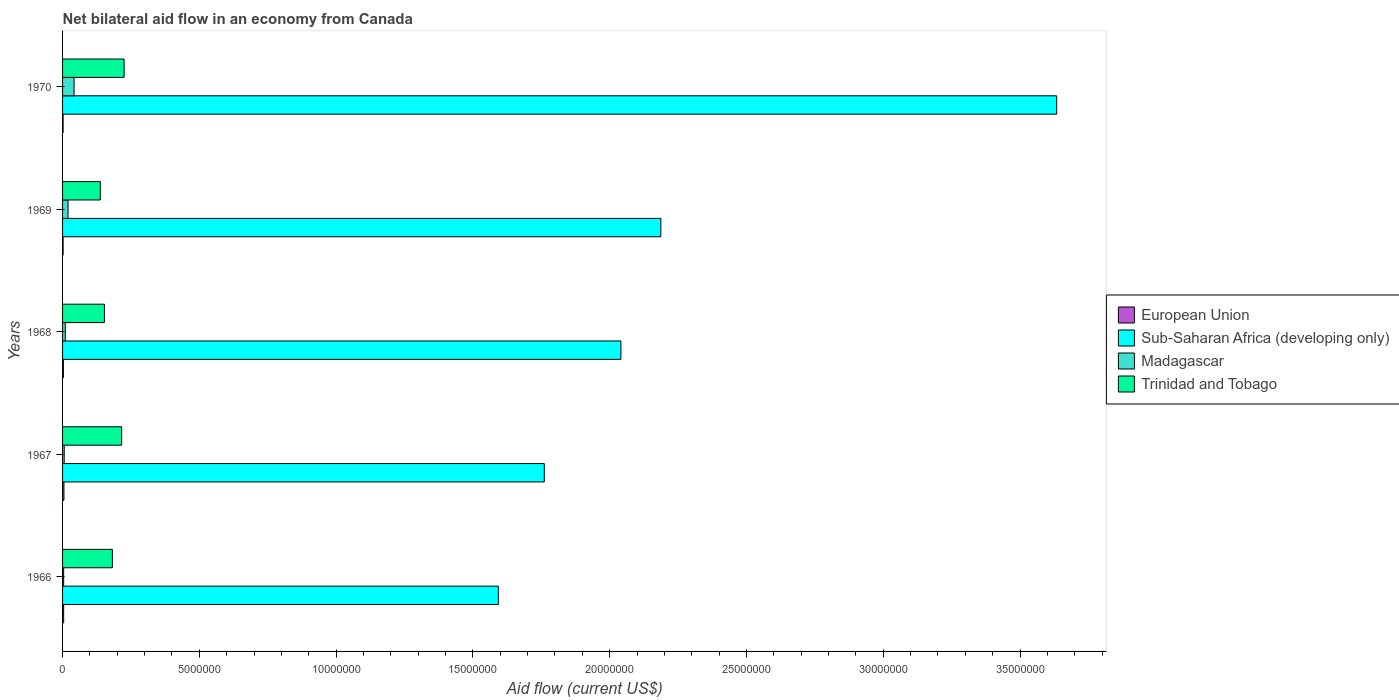Are the number of bars on each tick of the Y-axis equal?
Keep it short and to the point. Yes. What is the label of the 5th group of bars from the top?
Keep it short and to the point. 1966. In how many cases, is the number of bars for a given year not equal to the number of legend labels?
Your answer should be very brief. 0. What is the net bilateral aid flow in Sub-Saharan Africa (developing only) in 1970?
Keep it short and to the point. 3.63e+07. Across all years, what is the maximum net bilateral aid flow in Trinidad and Tobago?
Ensure brevity in your answer.  2.25e+06. Across all years, what is the minimum net bilateral aid flow in Trinidad and Tobago?
Your answer should be compact. 1.38e+06. In which year was the net bilateral aid flow in Madagascar maximum?
Your answer should be compact. 1970. In which year was the net bilateral aid flow in Madagascar minimum?
Your answer should be very brief. 1966. What is the total net bilateral aid flow in European Union in the graph?
Offer a very short reply. 1.60e+05. What is the difference between the net bilateral aid flow in Trinidad and Tobago in 1967 and that in 1970?
Your answer should be very brief. -9.00e+04. What is the difference between the net bilateral aid flow in Trinidad and Tobago in 1970 and the net bilateral aid flow in Madagascar in 1969?
Your answer should be compact. 2.05e+06. What is the average net bilateral aid flow in Trinidad and Tobago per year?
Offer a terse response. 1.83e+06. In the year 1969, what is the difference between the net bilateral aid flow in Madagascar and net bilateral aid flow in Trinidad and Tobago?
Keep it short and to the point. -1.18e+06. In how many years, is the net bilateral aid flow in Sub-Saharan Africa (developing only) greater than 17000000 US$?
Your answer should be compact. 4. What is the ratio of the net bilateral aid flow in Madagascar in 1966 to that in 1969?
Offer a terse response. 0.2. Is the difference between the net bilateral aid flow in Madagascar in 1968 and 1970 greater than the difference between the net bilateral aid flow in Trinidad and Tobago in 1968 and 1970?
Your answer should be compact. Yes. What is the difference between the highest and the second highest net bilateral aid flow in European Union?
Keep it short and to the point. 10000. What is the difference between the highest and the lowest net bilateral aid flow in Sub-Saharan Africa (developing only)?
Make the answer very short. 2.04e+07. In how many years, is the net bilateral aid flow in Madagascar greater than the average net bilateral aid flow in Madagascar taken over all years?
Ensure brevity in your answer.  2. Is the sum of the net bilateral aid flow in Madagascar in 1966 and 1969 greater than the maximum net bilateral aid flow in European Union across all years?
Give a very brief answer. Yes. Is it the case that in every year, the sum of the net bilateral aid flow in Sub-Saharan Africa (developing only) and net bilateral aid flow in Madagascar is greater than the sum of net bilateral aid flow in European Union and net bilateral aid flow in Trinidad and Tobago?
Provide a succinct answer. Yes. What does the 2nd bar from the top in 1966 represents?
Your response must be concise. Madagascar. Are all the bars in the graph horizontal?
Your response must be concise. Yes. How many years are there in the graph?
Offer a terse response. 5. Where does the legend appear in the graph?
Keep it short and to the point. Center right. How are the legend labels stacked?
Your answer should be compact. Vertical. What is the title of the graph?
Make the answer very short. Net bilateral aid flow in an economy from Canada. What is the label or title of the Y-axis?
Give a very brief answer. Years. What is the Aid flow (current US$) in Sub-Saharan Africa (developing only) in 1966?
Offer a terse response. 1.59e+07. What is the Aid flow (current US$) in Trinidad and Tobago in 1966?
Your response must be concise. 1.82e+06. What is the Aid flow (current US$) in European Union in 1967?
Your answer should be very brief. 5.00e+04. What is the Aid flow (current US$) in Sub-Saharan Africa (developing only) in 1967?
Offer a terse response. 1.76e+07. What is the Aid flow (current US$) in Madagascar in 1967?
Keep it short and to the point. 6.00e+04. What is the Aid flow (current US$) in Trinidad and Tobago in 1967?
Make the answer very short. 2.16e+06. What is the Aid flow (current US$) of European Union in 1968?
Provide a short and direct response. 3.00e+04. What is the Aid flow (current US$) in Sub-Saharan Africa (developing only) in 1968?
Offer a terse response. 2.04e+07. What is the Aid flow (current US$) in Trinidad and Tobago in 1968?
Offer a very short reply. 1.53e+06. What is the Aid flow (current US$) in Sub-Saharan Africa (developing only) in 1969?
Provide a succinct answer. 2.19e+07. What is the Aid flow (current US$) in Madagascar in 1969?
Offer a terse response. 2.00e+05. What is the Aid flow (current US$) in Trinidad and Tobago in 1969?
Your answer should be compact. 1.38e+06. What is the Aid flow (current US$) of Sub-Saharan Africa (developing only) in 1970?
Offer a very short reply. 3.63e+07. What is the Aid flow (current US$) of Trinidad and Tobago in 1970?
Provide a succinct answer. 2.25e+06. Across all years, what is the maximum Aid flow (current US$) in European Union?
Your answer should be compact. 5.00e+04. Across all years, what is the maximum Aid flow (current US$) in Sub-Saharan Africa (developing only)?
Give a very brief answer. 3.63e+07. Across all years, what is the maximum Aid flow (current US$) in Trinidad and Tobago?
Provide a succinct answer. 2.25e+06. Across all years, what is the minimum Aid flow (current US$) of Sub-Saharan Africa (developing only)?
Give a very brief answer. 1.59e+07. Across all years, what is the minimum Aid flow (current US$) in Madagascar?
Make the answer very short. 4.00e+04. Across all years, what is the minimum Aid flow (current US$) of Trinidad and Tobago?
Provide a short and direct response. 1.38e+06. What is the total Aid flow (current US$) in European Union in the graph?
Give a very brief answer. 1.60e+05. What is the total Aid flow (current US$) of Sub-Saharan Africa (developing only) in the graph?
Your response must be concise. 1.12e+08. What is the total Aid flow (current US$) in Madagascar in the graph?
Provide a short and direct response. 8.20e+05. What is the total Aid flow (current US$) of Trinidad and Tobago in the graph?
Make the answer very short. 9.14e+06. What is the difference between the Aid flow (current US$) of European Union in 1966 and that in 1967?
Provide a succinct answer. -10000. What is the difference between the Aid flow (current US$) of Sub-Saharan Africa (developing only) in 1966 and that in 1967?
Provide a short and direct response. -1.68e+06. What is the difference between the Aid flow (current US$) in Trinidad and Tobago in 1966 and that in 1967?
Your response must be concise. -3.40e+05. What is the difference between the Aid flow (current US$) of Sub-Saharan Africa (developing only) in 1966 and that in 1968?
Make the answer very short. -4.48e+06. What is the difference between the Aid flow (current US$) of European Union in 1966 and that in 1969?
Your response must be concise. 2.00e+04. What is the difference between the Aid flow (current US$) of Sub-Saharan Africa (developing only) in 1966 and that in 1969?
Your answer should be very brief. -5.94e+06. What is the difference between the Aid flow (current US$) in European Union in 1966 and that in 1970?
Your answer should be very brief. 2.00e+04. What is the difference between the Aid flow (current US$) in Sub-Saharan Africa (developing only) in 1966 and that in 1970?
Make the answer very short. -2.04e+07. What is the difference between the Aid flow (current US$) in Madagascar in 1966 and that in 1970?
Offer a terse response. -3.80e+05. What is the difference between the Aid flow (current US$) of Trinidad and Tobago in 1966 and that in 1970?
Provide a succinct answer. -4.30e+05. What is the difference between the Aid flow (current US$) in European Union in 1967 and that in 1968?
Offer a terse response. 2.00e+04. What is the difference between the Aid flow (current US$) in Sub-Saharan Africa (developing only) in 1967 and that in 1968?
Your response must be concise. -2.80e+06. What is the difference between the Aid flow (current US$) in Madagascar in 1967 and that in 1968?
Offer a very short reply. -4.00e+04. What is the difference between the Aid flow (current US$) of Trinidad and Tobago in 1967 and that in 1968?
Provide a short and direct response. 6.30e+05. What is the difference between the Aid flow (current US$) in Sub-Saharan Africa (developing only) in 1967 and that in 1969?
Offer a very short reply. -4.26e+06. What is the difference between the Aid flow (current US$) in Madagascar in 1967 and that in 1969?
Offer a very short reply. -1.40e+05. What is the difference between the Aid flow (current US$) of Trinidad and Tobago in 1967 and that in 1969?
Keep it short and to the point. 7.80e+05. What is the difference between the Aid flow (current US$) in European Union in 1967 and that in 1970?
Your answer should be compact. 3.00e+04. What is the difference between the Aid flow (current US$) of Sub-Saharan Africa (developing only) in 1967 and that in 1970?
Ensure brevity in your answer.  -1.87e+07. What is the difference between the Aid flow (current US$) of Madagascar in 1967 and that in 1970?
Offer a very short reply. -3.60e+05. What is the difference between the Aid flow (current US$) in Trinidad and Tobago in 1967 and that in 1970?
Keep it short and to the point. -9.00e+04. What is the difference between the Aid flow (current US$) of Sub-Saharan Africa (developing only) in 1968 and that in 1969?
Offer a very short reply. -1.46e+06. What is the difference between the Aid flow (current US$) in Madagascar in 1968 and that in 1969?
Give a very brief answer. -1.00e+05. What is the difference between the Aid flow (current US$) in Trinidad and Tobago in 1968 and that in 1969?
Your response must be concise. 1.50e+05. What is the difference between the Aid flow (current US$) in European Union in 1968 and that in 1970?
Your answer should be very brief. 10000. What is the difference between the Aid flow (current US$) in Sub-Saharan Africa (developing only) in 1968 and that in 1970?
Provide a short and direct response. -1.59e+07. What is the difference between the Aid flow (current US$) in Madagascar in 1968 and that in 1970?
Provide a succinct answer. -3.20e+05. What is the difference between the Aid flow (current US$) of Trinidad and Tobago in 1968 and that in 1970?
Your response must be concise. -7.20e+05. What is the difference between the Aid flow (current US$) of Sub-Saharan Africa (developing only) in 1969 and that in 1970?
Provide a short and direct response. -1.45e+07. What is the difference between the Aid flow (current US$) of Trinidad and Tobago in 1969 and that in 1970?
Offer a very short reply. -8.70e+05. What is the difference between the Aid flow (current US$) in European Union in 1966 and the Aid flow (current US$) in Sub-Saharan Africa (developing only) in 1967?
Give a very brief answer. -1.76e+07. What is the difference between the Aid flow (current US$) in European Union in 1966 and the Aid flow (current US$) in Madagascar in 1967?
Ensure brevity in your answer.  -2.00e+04. What is the difference between the Aid flow (current US$) of European Union in 1966 and the Aid flow (current US$) of Trinidad and Tobago in 1967?
Your answer should be compact. -2.12e+06. What is the difference between the Aid flow (current US$) in Sub-Saharan Africa (developing only) in 1966 and the Aid flow (current US$) in Madagascar in 1967?
Your answer should be compact. 1.59e+07. What is the difference between the Aid flow (current US$) of Sub-Saharan Africa (developing only) in 1966 and the Aid flow (current US$) of Trinidad and Tobago in 1967?
Offer a terse response. 1.38e+07. What is the difference between the Aid flow (current US$) in Madagascar in 1966 and the Aid flow (current US$) in Trinidad and Tobago in 1967?
Offer a terse response. -2.12e+06. What is the difference between the Aid flow (current US$) of European Union in 1966 and the Aid flow (current US$) of Sub-Saharan Africa (developing only) in 1968?
Make the answer very short. -2.04e+07. What is the difference between the Aid flow (current US$) of European Union in 1966 and the Aid flow (current US$) of Trinidad and Tobago in 1968?
Provide a succinct answer. -1.49e+06. What is the difference between the Aid flow (current US$) in Sub-Saharan Africa (developing only) in 1966 and the Aid flow (current US$) in Madagascar in 1968?
Your response must be concise. 1.58e+07. What is the difference between the Aid flow (current US$) in Sub-Saharan Africa (developing only) in 1966 and the Aid flow (current US$) in Trinidad and Tobago in 1968?
Ensure brevity in your answer.  1.44e+07. What is the difference between the Aid flow (current US$) of Madagascar in 1966 and the Aid flow (current US$) of Trinidad and Tobago in 1968?
Provide a short and direct response. -1.49e+06. What is the difference between the Aid flow (current US$) in European Union in 1966 and the Aid flow (current US$) in Sub-Saharan Africa (developing only) in 1969?
Offer a terse response. -2.18e+07. What is the difference between the Aid flow (current US$) of European Union in 1966 and the Aid flow (current US$) of Trinidad and Tobago in 1969?
Make the answer very short. -1.34e+06. What is the difference between the Aid flow (current US$) of Sub-Saharan Africa (developing only) in 1966 and the Aid flow (current US$) of Madagascar in 1969?
Ensure brevity in your answer.  1.57e+07. What is the difference between the Aid flow (current US$) in Sub-Saharan Africa (developing only) in 1966 and the Aid flow (current US$) in Trinidad and Tobago in 1969?
Make the answer very short. 1.46e+07. What is the difference between the Aid flow (current US$) of Madagascar in 1966 and the Aid flow (current US$) of Trinidad and Tobago in 1969?
Ensure brevity in your answer.  -1.34e+06. What is the difference between the Aid flow (current US$) in European Union in 1966 and the Aid flow (current US$) in Sub-Saharan Africa (developing only) in 1970?
Your answer should be very brief. -3.63e+07. What is the difference between the Aid flow (current US$) in European Union in 1966 and the Aid flow (current US$) in Madagascar in 1970?
Provide a succinct answer. -3.80e+05. What is the difference between the Aid flow (current US$) of European Union in 1966 and the Aid flow (current US$) of Trinidad and Tobago in 1970?
Keep it short and to the point. -2.21e+06. What is the difference between the Aid flow (current US$) in Sub-Saharan Africa (developing only) in 1966 and the Aid flow (current US$) in Madagascar in 1970?
Your response must be concise. 1.55e+07. What is the difference between the Aid flow (current US$) of Sub-Saharan Africa (developing only) in 1966 and the Aid flow (current US$) of Trinidad and Tobago in 1970?
Your answer should be very brief. 1.37e+07. What is the difference between the Aid flow (current US$) in Madagascar in 1966 and the Aid flow (current US$) in Trinidad and Tobago in 1970?
Make the answer very short. -2.21e+06. What is the difference between the Aid flow (current US$) of European Union in 1967 and the Aid flow (current US$) of Sub-Saharan Africa (developing only) in 1968?
Keep it short and to the point. -2.04e+07. What is the difference between the Aid flow (current US$) in European Union in 1967 and the Aid flow (current US$) in Madagascar in 1968?
Give a very brief answer. -5.00e+04. What is the difference between the Aid flow (current US$) in European Union in 1967 and the Aid flow (current US$) in Trinidad and Tobago in 1968?
Your answer should be compact. -1.48e+06. What is the difference between the Aid flow (current US$) of Sub-Saharan Africa (developing only) in 1967 and the Aid flow (current US$) of Madagascar in 1968?
Provide a short and direct response. 1.75e+07. What is the difference between the Aid flow (current US$) of Sub-Saharan Africa (developing only) in 1967 and the Aid flow (current US$) of Trinidad and Tobago in 1968?
Provide a short and direct response. 1.61e+07. What is the difference between the Aid flow (current US$) of Madagascar in 1967 and the Aid flow (current US$) of Trinidad and Tobago in 1968?
Your response must be concise. -1.47e+06. What is the difference between the Aid flow (current US$) in European Union in 1967 and the Aid flow (current US$) in Sub-Saharan Africa (developing only) in 1969?
Your response must be concise. -2.18e+07. What is the difference between the Aid flow (current US$) in European Union in 1967 and the Aid flow (current US$) in Trinidad and Tobago in 1969?
Your answer should be compact. -1.33e+06. What is the difference between the Aid flow (current US$) of Sub-Saharan Africa (developing only) in 1967 and the Aid flow (current US$) of Madagascar in 1969?
Offer a terse response. 1.74e+07. What is the difference between the Aid flow (current US$) in Sub-Saharan Africa (developing only) in 1967 and the Aid flow (current US$) in Trinidad and Tobago in 1969?
Your response must be concise. 1.62e+07. What is the difference between the Aid flow (current US$) of Madagascar in 1967 and the Aid flow (current US$) of Trinidad and Tobago in 1969?
Your response must be concise. -1.32e+06. What is the difference between the Aid flow (current US$) in European Union in 1967 and the Aid flow (current US$) in Sub-Saharan Africa (developing only) in 1970?
Your answer should be compact. -3.63e+07. What is the difference between the Aid flow (current US$) in European Union in 1967 and the Aid flow (current US$) in Madagascar in 1970?
Offer a terse response. -3.70e+05. What is the difference between the Aid flow (current US$) of European Union in 1967 and the Aid flow (current US$) of Trinidad and Tobago in 1970?
Offer a very short reply. -2.20e+06. What is the difference between the Aid flow (current US$) in Sub-Saharan Africa (developing only) in 1967 and the Aid flow (current US$) in Madagascar in 1970?
Make the answer very short. 1.72e+07. What is the difference between the Aid flow (current US$) in Sub-Saharan Africa (developing only) in 1967 and the Aid flow (current US$) in Trinidad and Tobago in 1970?
Ensure brevity in your answer.  1.54e+07. What is the difference between the Aid flow (current US$) in Madagascar in 1967 and the Aid flow (current US$) in Trinidad and Tobago in 1970?
Your answer should be compact. -2.19e+06. What is the difference between the Aid flow (current US$) of European Union in 1968 and the Aid flow (current US$) of Sub-Saharan Africa (developing only) in 1969?
Provide a short and direct response. -2.18e+07. What is the difference between the Aid flow (current US$) of European Union in 1968 and the Aid flow (current US$) of Madagascar in 1969?
Your answer should be compact. -1.70e+05. What is the difference between the Aid flow (current US$) of European Union in 1968 and the Aid flow (current US$) of Trinidad and Tobago in 1969?
Provide a short and direct response. -1.35e+06. What is the difference between the Aid flow (current US$) in Sub-Saharan Africa (developing only) in 1968 and the Aid flow (current US$) in Madagascar in 1969?
Keep it short and to the point. 2.02e+07. What is the difference between the Aid flow (current US$) of Sub-Saharan Africa (developing only) in 1968 and the Aid flow (current US$) of Trinidad and Tobago in 1969?
Ensure brevity in your answer.  1.90e+07. What is the difference between the Aid flow (current US$) in Madagascar in 1968 and the Aid flow (current US$) in Trinidad and Tobago in 1969?
Provide a short and direct response. -1.28e+06. What is the difference between the Aid flow (current US$) in European Union in 1968 and the Aid flow (current US$) in Sub-Saharan Africa (developing only) in 1970?
Your answer should be very brief. -3.63e+07. What is the difference between the Aid flow (current US$) in European Union in 1968 and the Aid flow (current US$) in Madagascar in 1970?
Your answer should be compact. -3.90e+05. What is the difference between the Aid flow (current US$) in European Union in 1968 and the Aid flow (current US$) in Trinidad and Tobago in 1970?
Ensure brevity in your answer.  -2.22e+06. What is the difference between the Aid flow (current US$) in Sub-Saharan Africa (developing only) in 1968 and the Aid flow (current US$) in Madagascar in 1970?
Provide a succinct answer. 2.00e+07. What is the difference between the Aid flow (current US$) of Sub-Saharan Africa (developing only) in 1968 and the Aid flow (current US$) of Trinidad and Tobago in 1970?
Offer a terse response. 1.82e+07. What is the difference between the Aid flow (current US$) of Madagascar in 1968 and the Aid flow (current US$) of Trinidad and Tobago in 1970?
Your answer should be very brief. -2.15e+06. What is the difference between the Aid flow (current US$) of European Union in 1969 and the Aid flow (current US$) of Sub-Saharan Africa (developing only) in 1970?
Your answer should be very brief. -3.63e+07. What is the difference between the Aid flow (current US$) in European Union in 1969 and the Aid flow (current US$) in Madagascar in 1970?
Your answer should be very brief. -4.00e+05. What is the difference between the Aid flow (current US$) in European Union in 1969 and the Aid flow (current US$) in Trinidad and Tobago in 1970?
Your answer should be very brief. -2.23e+06. What is the difference between the Aid flow (current US$) in Sub-Saharan Africa (developing only) in 1969 and the Aid flow (current US$) in Madagascar in 1970?
Offer a very short reply. 2.14e+07. What is the difference between the Aid flow (current US$) of Sub-Saharan Africa (developing only) in 1969 and the Aid flow (current US$) of Trinidad and Tobago in 1970?
Make the answer very short. 1.96e+07. What is the difference between the Aid flow (current US$) of Madagascar in 1969 and the Aid flow (current US$) of Trinidad and Tobago in 1970?
Your answer should be compact. -2.05e+06. What is the average Aid flow (current US$) in European Union per year?
Your response must be concise. 3.20e+04. What is the average Aid flow (current US$) of Sub-Saharan Africa (developing only) per year?
Provide a succinct answer. 2.24e+07. What is the average Aid flow (current US$) in Madagascar per year?
Keep it short and to the point. 1.64e+05. What is the average Aid flow (current US$) in Trinidad and Tobago per year?
Make the answer very short. 1.83e+06. In the year 1966, what is the difference between the Aid flow (current US$) in European Union and Aid flow (current US$) in Sub-Saharan Africa (developing only)?
Ensure brevity in your answer.  -1.59e+07. In the year 1966, what is the difference between the Aid flow (current US$) in European Union and Aid flow (current US$) in Madagascar?
Offer a very short reply. 0. In the year 1966, what is the difference between the Aid flow (current US$) in European Union and Aid flow (current US$) in Trinidad and Tobago?
Offer a terse response. -1.78e+06. In the year 1966, what is the difference between the Aid flow (current US$) of Sub-Saharan Africa (developing only) and Aid flow (current US$) of Madagascar?
Make the answer very short. 1.59e+07. In the year 1966, what is the difference between the Aid flow (current US$) in Sub-Saharan Africa (developing only) and Aid flow (current US$) in Trinidad and Tobago?
Provide a short and direct response. 1.41e+07. In the year 1966, what is the difference between the Aid flow (current US$) in Madagascar and Aid flow (current US$) in Trinidad and Tobago?
Offer a terse response. -1.78e+06. In the year 1967, what is the difference between the Aid flow (current US$) of European Union and Aid flow (current US$) of Sub-Saharan Africa (developing only)?
Offer a very short reply. -1.76e+07. In the year 1967, what is the difference between the Aid flow (current US$) of European Union and Aid flow (current US$) of Madagascar?
Give a very brief answer. -10000. In the year 1967, what is the difference between the Aid flow (current US$) of European Union and Aid flow (current US$) of Trinidad and Tobago?
Provide a succinct answer. -2.11e+06. In the year 1967, what is the difference between the Aid flow (current US$) in Sub-Saharan Africa (developing only) and Aid flow (current US$) in Madagascar?
Ensure brevity in your answer.  1.76e+07. In the year 1967, what is the difference between the Aid flow (current US$) in Sub-Saharan Africa (developing only) and Aid flow (current US$) in Trinidad and Tobago?
Keep it short and to the point. 1.54e+07. In the year 1967, what is the difference between the Aid flow (current US$) in Madagascar and Aid flow (current US$) in Trinidad and Tobago?
Your answer should be very brief. -2.10e+06. In the year 1968, what is the difference between the Aid flow (current US$) in European Union and Aid flow (current US$) in Sub-Saharan Africa (developing only)?
Offer a terse response. -2.04e+07. In the year 1968, what is the difference between the Aid flow (current US$) of European Union and Aid flow (current US$) of Trinidad and Tobago?
Give a very brief answer. -1.50e+06. In the year 1968, what is the difference between the Aid flow (current US$) of Sub-Saharan Africa (developing only) and Aid flow (current US$) of Madagascar?
Your answer should be compact. 2.03e+07. In the year 1968, what is the difference between the Aid flow (current US$) of Sub-Saharan Africa (developing only) and Aid flow (current US$) of Trinidad and Tobago?
Your response must be concise. 1.89e+07. In the year 1968, what is the difference between the Aid flow (current US$) of Madagascar and Aid flow (current US$) of Trinidad and Tobago?
Keep it short and to the point. -1.43e+06. In the year 1969, what is the difference between the Aid flow (current US$) in European Union and Aid flow (current US$) in Sub-Saharan Africa (developing only)?
Keep it short and to the point. -2.18e+07. In the year 1969, what is the difference between the Aid flow (current US$) in European Union and Aid flow (current US$) in Trinidad and Tobago?
Offer a very short reply. -1.36e+06. In the year 1969, what is the difference between the Aid flow (current US$) of Sub-Saharan Africa (developing only) and Aid flow (current US$) of Madagascar?
Your answer should be very brief. 2.17e+07. In the year 1969, what is the difference between the Aid flow (current US$) in Sub-Saharan Africa (developing only) and Aid flow (current US$) in Trinidad and Tobago?
Your answer should be compact. 2.05e+07. In the year 1969, what is the difference between the Aid flow (current US$) in Madagascar and Aid flow (current US$) in Trinidad and Tobago?
Provide a short and direct response. -1.18e+06. In the year 1970, what is the difference between the Aid flow (current US$) of European Union and Aid flow (current US$) of Sub-Saharan Africa (developing only)?
Ensure brevity in your answer.  -3.63e+07. In the year 1970, what is the difference between the Aid flow (current US$) in European Union and Aid flow (current US$) in Madagascar?
Your answer should be very brief. -4.00e+05. In the year 1970, what is the difference between the Aid flow (current US$) in European Union and Aid flow (current US$) in Trinidad and Tobago?
Offer a very short reply. -2.23e+06. In the year 1970, what is the difference between the Aid flow (current US$) in Sub-Saharan Africa (developing only) and Aid flow (current US$) in Madagascar?
Offer a terse response. 3.59e+07. In the year 1970, what is the difference between the Aid flow (current US$) in Sub-Saharan Africa (developing only) and Aid flow (current US$) in Trinidad and Tobago?
Make the answer very short. 3.41e+07. In the year 1970, what is the difference between the Aid flow (current US$) of Madagascar and Aid flow (current US$) of Trinidad and Tobago?
Offer a terse response. -1.83e+06. What is the ratio of the Aid flow (current US$) in Sub-Saharan Africa (developing only) in 1966 to that in 1967?
Your answer should be compact. 0.9. What is the ratio of the Aid flow (current US$) of Madagascar in 1966 to that in 1967?
Provide a short and direct response. 0.67. What is the ratio of the Aid flow (current US$) in Trinidad and Tobago in 1966 to that in 1967?
Ensure brevity in your answer.  0.84. What is the ratio of the Aid flow (current US$) in Sub-Saharan Africa (developing only) in 1966 to that in 1968?
Offer a terse response. 0.78. What is the ratio of the Aid flow (current US$) of Madagascar in 1966 to that in 1968?
Ensure brevity in your answer.  0.4. What is the ratio of the Aid flow (current US$) in Trinidad and Tobago in 1966 to that in 1968?
Provide a short and direct response. 1.19. What is the ratio of the Aid flow (current US$) in European Union in 1966 to that in 1969?
Provide a short and direct response. 2. What is the ratio of the Aid flow (current US$) in Sub-Saharan Africa (developing only) in 1966 to that in 1969?
Keep it short and to the point. 0.73. What is the ratio of the Aid flow (current US$) of Trinidad and Tobago in 1966 to that in 1969?
Your answer should be compact. 1.32. What is the ratio of the Aid flow (current US$) of Sub-Saharan Africa (developing only) in 1966 to that in 1970?
Offer a very short reply. 0.44. What is the ratio of the Aid flow (current US$) of Madagascar in 1966 to that in 1970?
Keep it short and to the point. 0.1. What is the ratio of the Aid flow (current US$) of Trinidad and Tobago in 1966 to that in 1970?
Your answer should be very brief. 0.81. What is the ratio of the Aid flow (current US$) in European Union in 1967 to that in 1968?
Your answer should be very brief. 1.67. What is the ratio of the Aid flow (current US$) of Sub-Saharan Africa (developing only) in 1967 to that in 1968?
Keep it short and to the point. 0.86. What is the ratio of the Aid flow (current US$) of Trinidad and Tobago in 1967 to that in 1968?
Make the answer very short. 1.41. What is the ratio of the Aid flow (current US$) in European Union in 1967 to that in 1969?
Make the answer very short. 2.5. What is the ratio of the Aid flow (current US$) in Sub-Saharan Africa (developing only) in 1967 to that in 1969?
Your answer should be very brief. 0.81. What is the ratio of the Aid flow (current US$) of Trinidad and Tobago in 1967 to that in 1969?
Provide a short and direct response. 1.57. What is the ratio of the Aid flow (current US$) of European Union in 1967 to that in 1970?
Ensure brevity in your answer.  2.5. What is the ratio of the Aid flow (current US$) in Sub-Saharan Africa (developing only) in 1967 to that in 1970?
Provide a short and direct response. 0.48. What is the ratio of the Aid flow (current US$) in Madagascar in 1967 to that in 1970?
Ensure brevity in your answer.  0.14. What is the ratio of the Aid flow (current US$) in Sub-Saharan Africa (developing only) in 1968 to that in 1969?
Your answer should be compact. 0.93. What is the ratio of the Aid flow (current US$) of Trinidad and Tobago in 1968 to that in 1969?
Your response must be concise. 1.11. What is the ratio of the Aid flow (current US$) of Sub-Saharan Africa (developing only) in 1968 to that in 1970?
Make the answer very short. 0.56. What is the ratio of the Aid flow (current US$) of Madagascar in 1968 to that in 1970?
Provide a succinct answer. 0.24. What is the ratio of the Aid flow (current US$) of Trinidad and Tobago in 1968 to that in 1970?
Offer a terse response. 0.68. What is the ratio of the Aid flow (current US$) in Sub-Saharan Africa (developing only) in 1969 to that in 1970?
Make the answer very short. 0.6. What is the ratio of the Aid flow (current US$) of Madagascar in 1969 to that in 1970?
Your response must be concise. 0.48. What is the ratio of the Aid flow (current US$) in Trinidad and Tobago in 1969 to that in 1970?
Ensure brevity in your answer.  0.61. What is the difference between the highest and the second highest Aid flow (current US$) in Sub-Saharan Africa (developing only)?
Provide a short and direct response. 1.45e+07. What is the difference between the highest and the second highest Aid flow (current US$) of Madagascar?
Offer a very short reply. 2.20e+05. What is the difference between the highest and the second highest Aid flow (current US$) in Trinidad and Tobago?
Offer a terse response. 9.00e+04. What is the difference between the highest and the lowest Aid flow (current US$) in Sub-Saharan Africa (developing only)?
Provide a short and direct response. 2.04e+07. What is the difference between the highest and the lowest Aid flow (current US$) of Madagascar?
Provide a succinct answer. 3.80e+05. What is the difference between the highest and the lowest Aid flow (current US$) of Trinidad and Tobago?
Your answer should be very brief. 8.70e+05. 